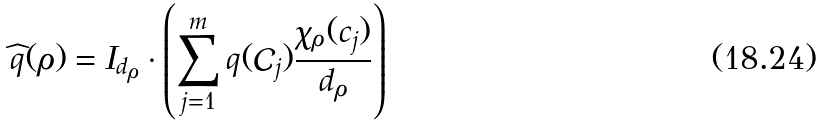<formula> <loc_0><loc_0><loc_500><loc_500>\widehat { q } ( \rho ) = I _ { d _ { \rho } } \cdot \left ( \sum _ { j = 1 } ^ { m } q ( \mathcal { C } _ { j } ) \frac { \chi _ { \rho } ( c _ { j } ) } { d _ { \rho } } \right )</formula> 